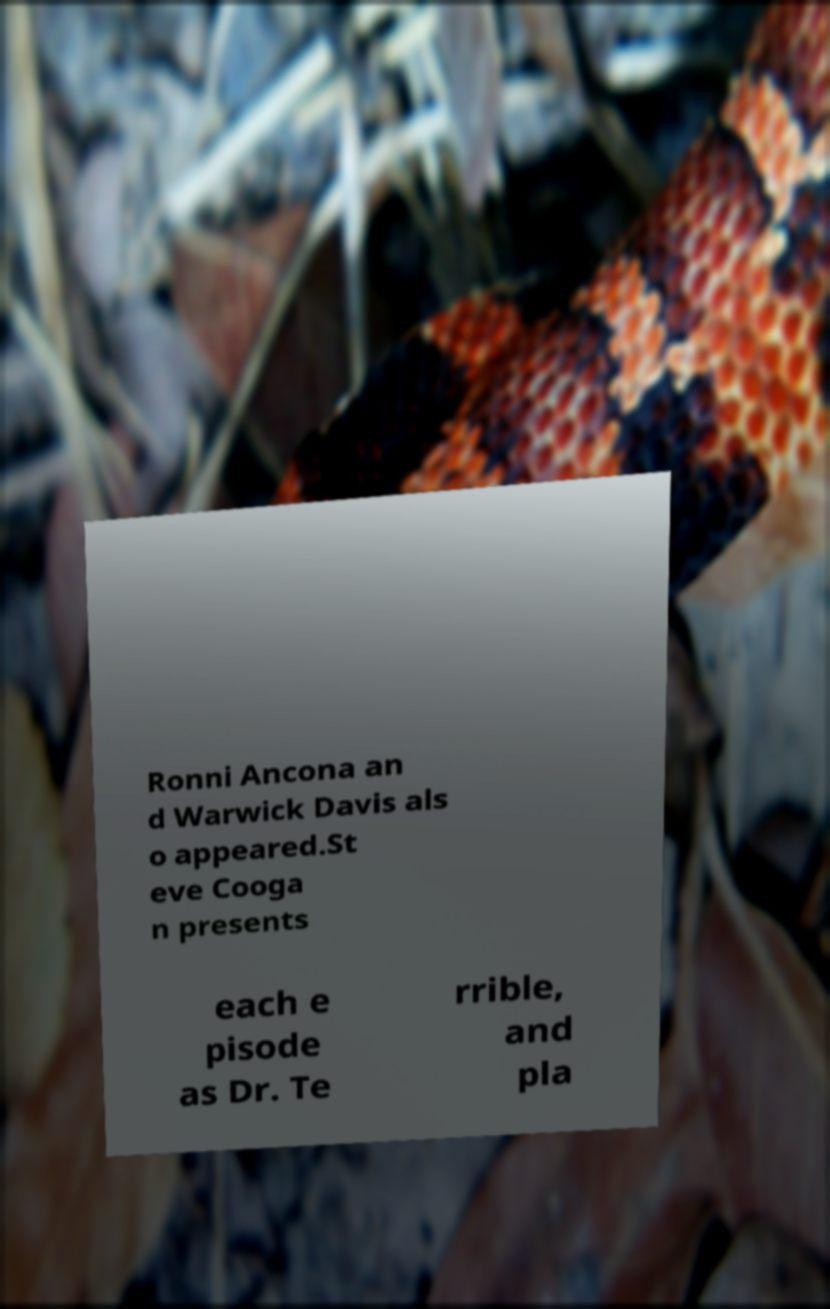Could you assist in decoding the text presented in this image and type it out clearly? Ronni Ancona an d Warwick Davis als o appeared.St eve Cooga n presents each e pisode as Dr. Te rrible, and pla 